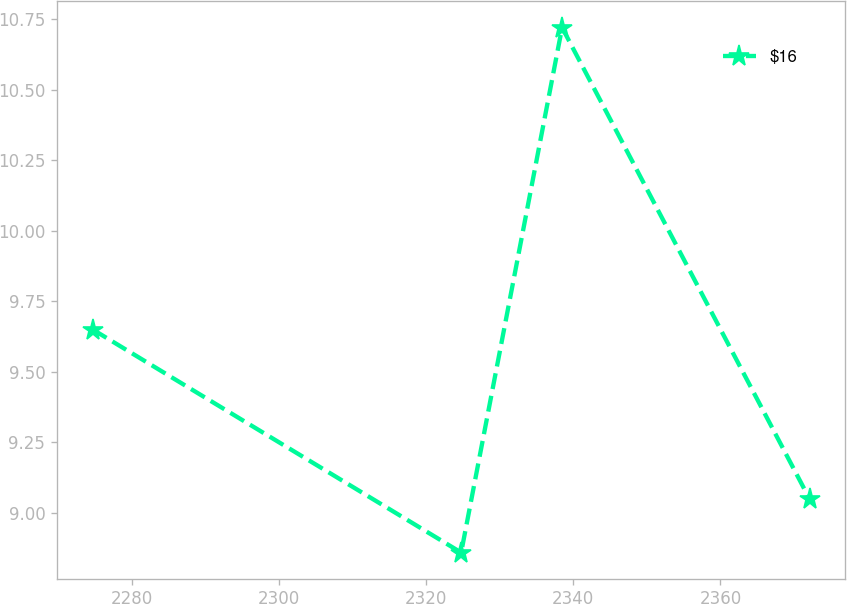Convert chart to OTSL. <chart><loc_0><loc_0><loc_500><loc_500><line_chart><ecel><fcel>$16<nl><fcel>2274.72<fcel>9.65<nl><fcel>2324.77<fcel>8.86<nl><fcel>2338.48<fcel>10.72<nl><fcel>2372.1<fcel>9.05<nl></chart> 